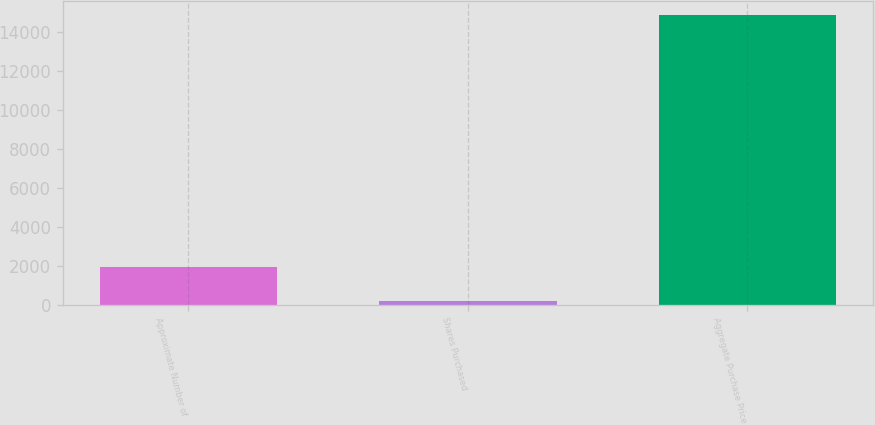Convert chart. <chart><loc_0><loc_0><loc_500><loc_500><bar_chart><fcel>Approximate Number of<fcel>Shares Purchased<fcel>Aggregate Purchase Price<nl><fcel>1934<fcel>180<fcel>14887<nl></chart> 